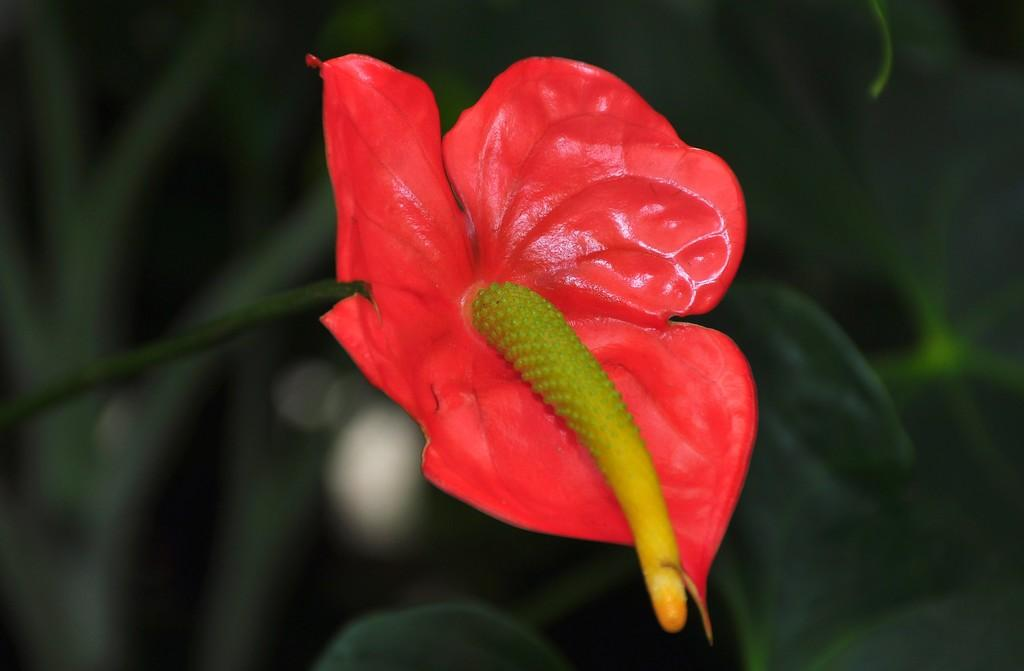What is the main subject of the image? There is a flower in the image. Can you describe any part of the flower besides the petals? Yes, there is a stem associated with the flower. How would you describe the background of the image? The background of the image is blurry. Can you tell me how many cows are visible in the image? There are no cows present in the image; it features a flower with a stem. What type of kitten can be seen playing with the flower in the image? There is no kitten present in the image, and therefore no such activity can be observed. 